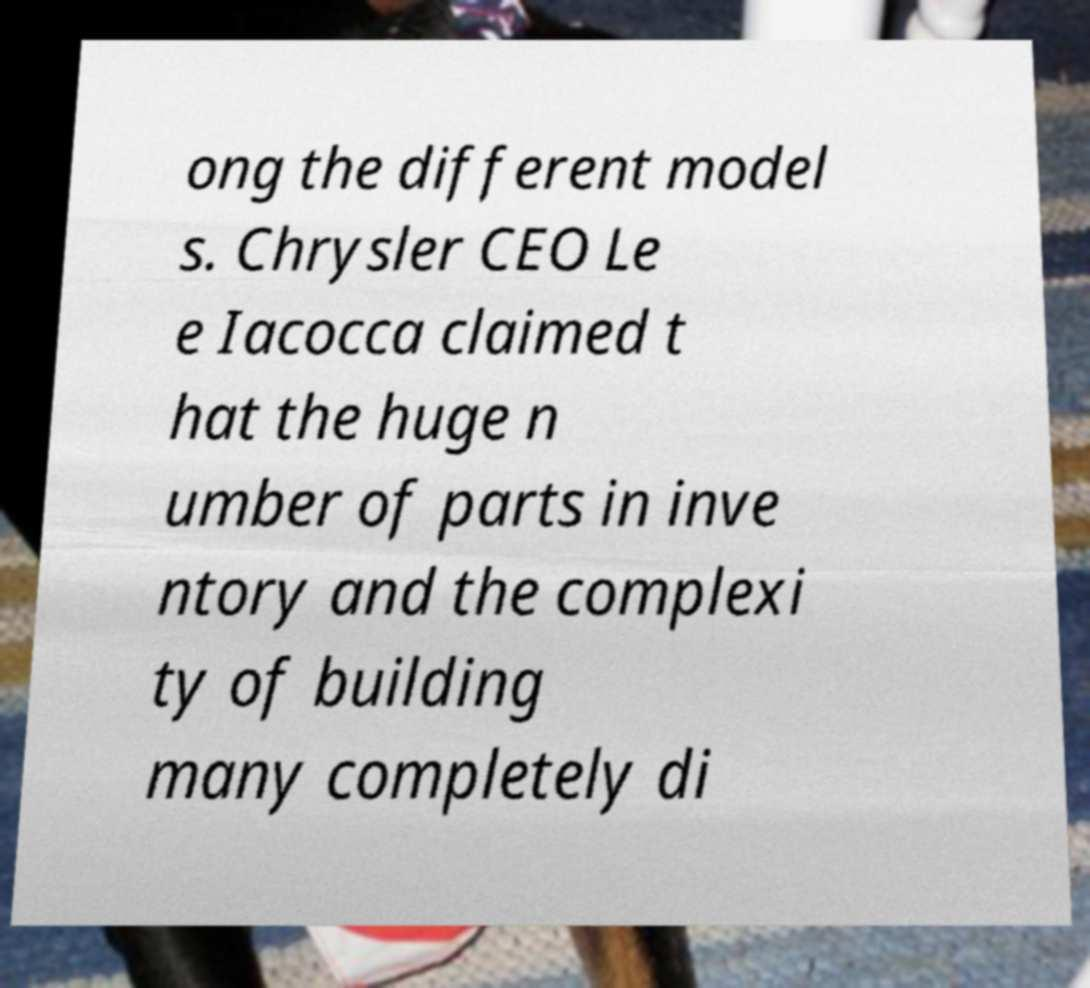Please read and relay the text visible in this image. What does it say? ong the different model s. Chrysler CEO Le e Iacocca claimed t hat the huge n umber of parts in inve ntory and the complexi ty of building many completely di 